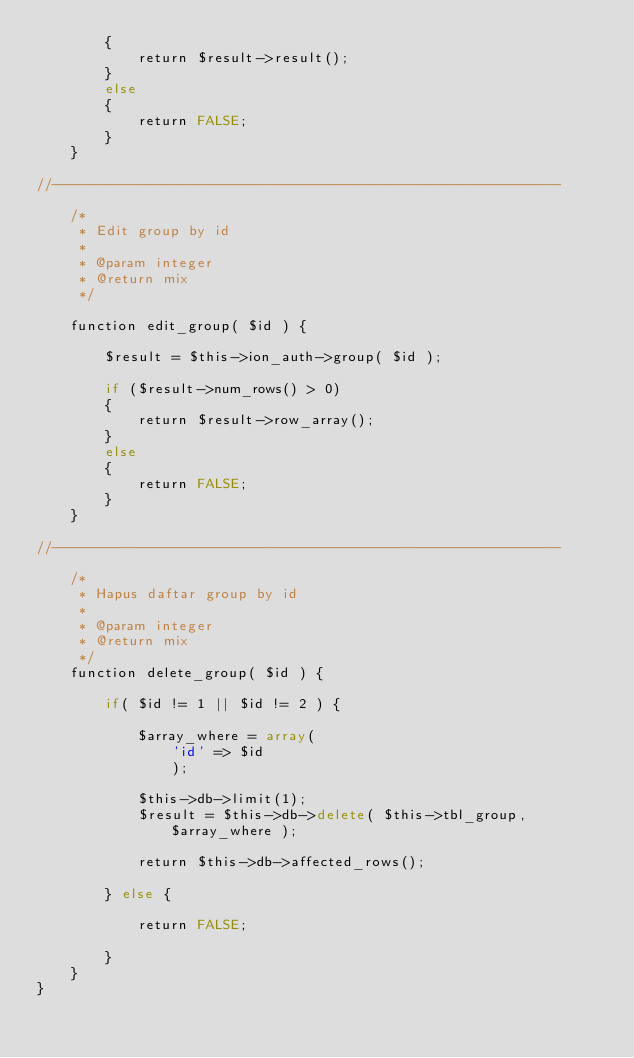Convert code to text. <code><loc_0><loc_0><loc_500><loc_500><_PHP_>		{
			return $result->result();
		}
		else
		{
			return FALSE;
		}
	}

//------------------------------------------------------------

	/*
	 * Edit group by id
	 *
	 * @param integer
	 * @return mix
	 */

	function edit_group( $id ) {

		$result = $this->ion_auth->group( $id );

		if ($result->num_rows() > 0)
		{
			return $result->row_array();
		}
		else
		{
			return FALSE;
		}
	}

//------------------------------------------------------------

	/*
	 * Hapus daftar group by id
	 *
	 * @param integer
	 * @return mix
	 */
	function delete_group( $id ) {

		if( $id != 1 || $id != 2 ) {

			$array_where = array(
				'id' => $id
				);

			$this->db->limit(1);
			$result = $this->db->delete( $this->tbl_group, $array_where );

			return $this->db->affected_rows();

		} else {

			return FALSE;

		}
	}
}
</code> 